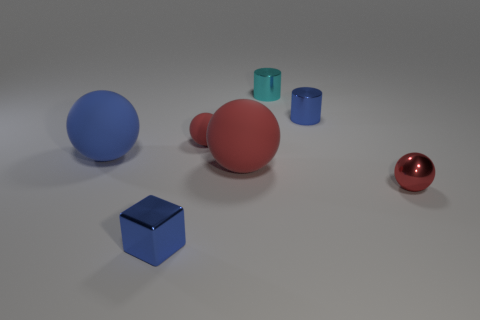Subtract all purple cylinders. How many red balls are left? 3 Add 1 large matte spheres. How many objects exist? 8 Subtract all balls. How many objects are left? 3 Add 7 tiny red metal objects. How many tiny red metal objects exist? 8 Subtract 1 blue balls. How many objects are left? 6 Subtract all tiny blue shiny things. Subtract all small blue cylinders. How many objects are left? 4 Add 3 small cyan shiny cylinders. How many small cyan shiny cylinders are left? 4 